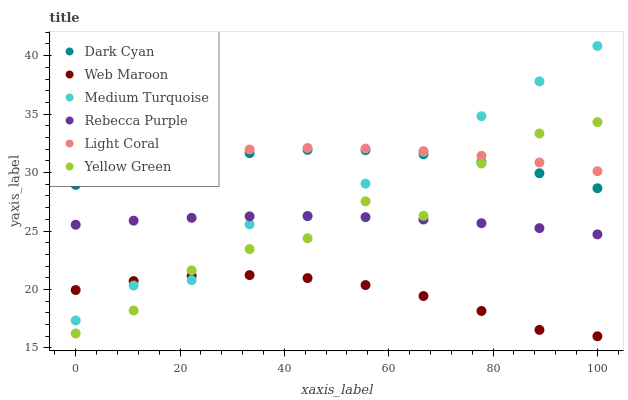Does Web Maroon have the minimum area under the curve?
Answer yes or no. Yes. Does Light Coral have the maximum area under the curve?
Answer yes or no. Yes. Does Light Coral have the minimum area under the curve?
Answer yes or no. No. Does Web Maroon have the maximum area under the curve?
Answer yes or no. No. Is Rebecca Purple the smoothest?
Answer yes or no. Yes. Is Yellow Green the roughest?
Answer yes or no. Yes. Is Web Maroon the smoothest?
Answer yes or no. No. Is Web Maroon the roughest?
Answer yes or no. No. Does Web Maroon have the lowest value?
Answer yes or no. Yes. Does Light Coral have the lowest value?
Answer yes or no. No. Does Medium Turquoise have the highest value?
Answer yes or no. Yes. Does Light Coral have the highest value?
Answer yes or no. No. Is Web Maroon less than Rebecca Purple?
Answer yes or no. Yes. Is Light Coral greater than Dark Cyan?
Answer yes or no. Yes. Does Yellow Green intersect Light Coral?
Answer yes or no. Yes. Is Yellow Green less than Light Coral?
Answer yes or no. No. Is Yellow Green greater than Light Coral?
Answer yes or no. No. Does Web Maroon intersect Rebecca Purple?
Answer yes or no. No. 